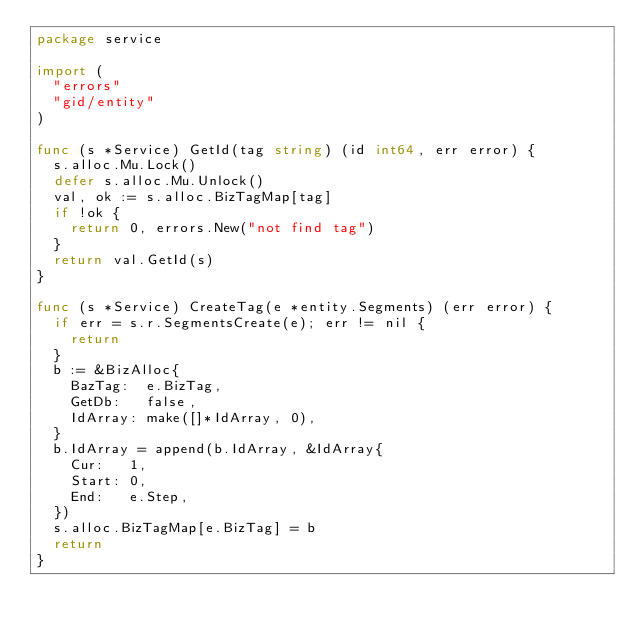Convert code to text. <code><loc_0><loc_0><loc_500><loc_500><_Go_>package service

import (
	"errors"
	"gid/entity"
)

func (s *Service) GetId(tag string) (id int64, err error) {
	s.alloc.Mu.Lock()
	defer s.alloc.Mu.Unlock()
	val, ok := s.alloc.BizTagMap[tag]
	if !ok {
		return 0, errors.New("not find tag")
	}
	return val.GetId(s)
}

func (s *Service) CreateTag(e *entity.Segments) (err error) {
	if err = s.r.SegmentsCreate(e); err != nil {
		return
	}
	b := &BizAlloc{
		BazTag:  e.BizTag,
		GetDb:   false,
		IdArray: make([]*IdArray, 0),
	}
	b.IdArray = append(b.IdArray, &IdArray{
		Cur:   1,
		Start: 0,
		End:   e.Step,
	})
	s.alloc.BizTagMap[e.BizTag] = b
	return
}
</code> 